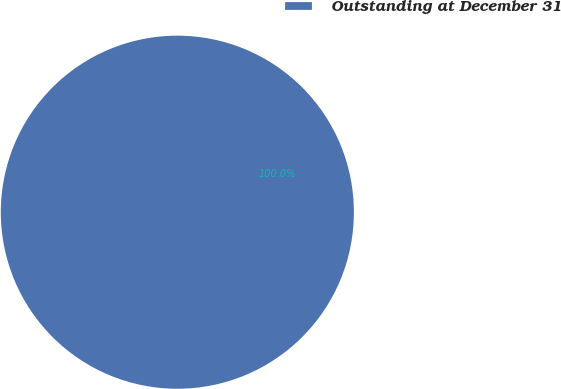Convert chart. <chart><loc_0><loc_0><loc_500><loc_500><pie_chart><fcel>Outstanding at December 31<nl><fcel>100.0%<nl></chart> 